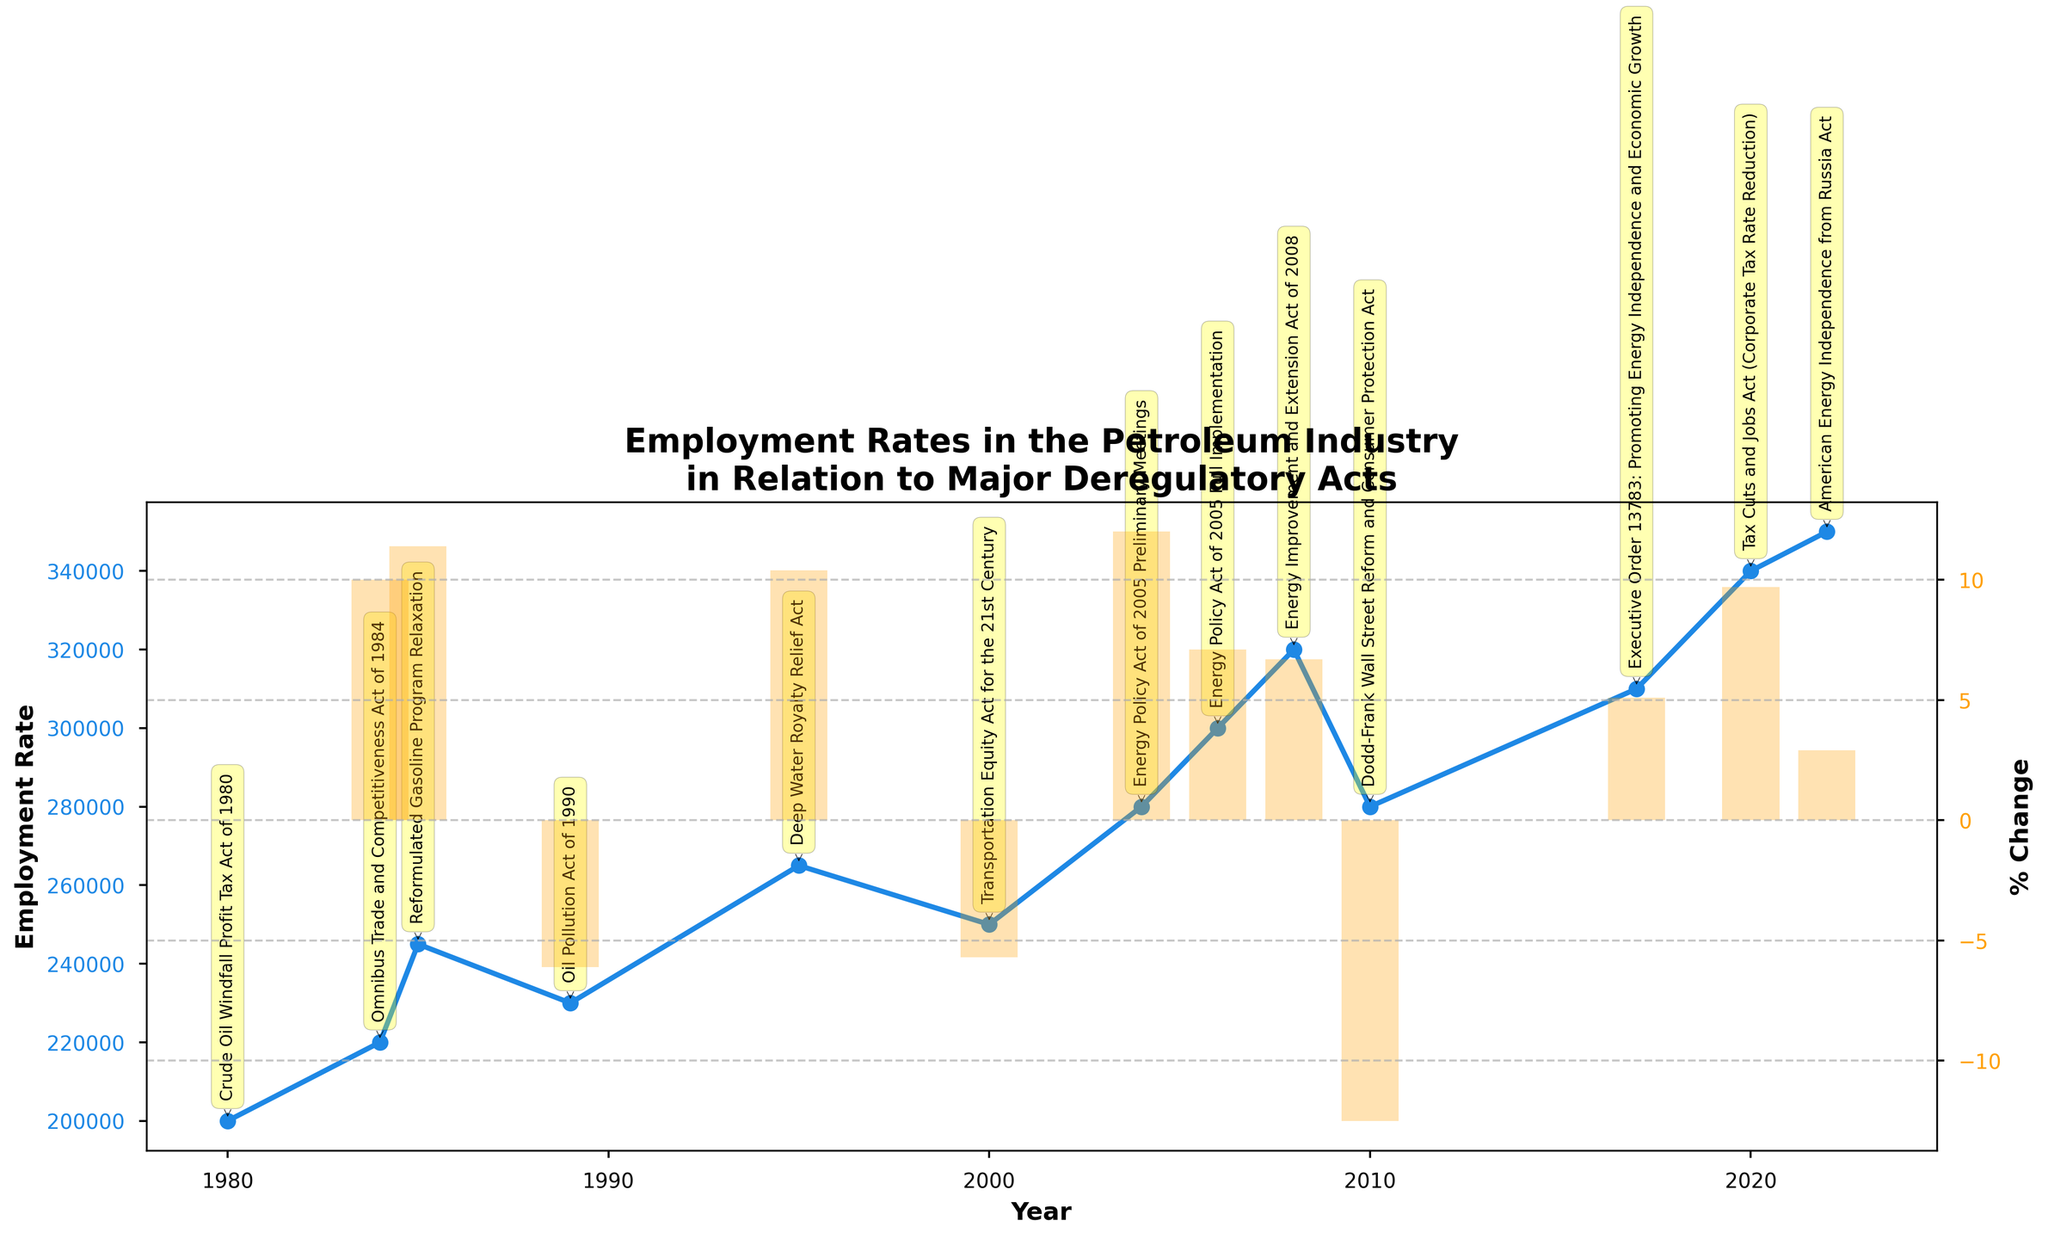What is the title of the figure? The title of the figure is displayed at the top and usually encapsulates the overall theme or purpose of the figure. Here it reads: 'Employment Rates in the Petroleum Industry in Relation to Major Deregulatory Acts'.
Answer: Employment Rates in the Petroleum Industry in Relation to Major Deregulatory Acts How many major deregulatory acts are annotated in the figure? By counting the number of deregulatory acts annotated, either from the yellow text boxes or the arrows pointing to specific years, we can determine the total number. There are 12 deregulatory acts annotated.
Answer: 12 What trend is observed in the employment rate between 1984 and 1985? Observing the line graph, the employment rate rose from 220,000 in 1984 to 245,000 in 1985.
Answer: Increased Which year shows the highest employment rate in the petroleum industry? Referring to the plot, the employment rate peaks at 350,000 in the year 2022.
Answer: 2022 What is the percentage change in employment rate in 2010, and what might have contributed to it? The bar corresponding to 2010 shows a -12.5% change, the largest negative percentage change. The annotated act in 2010 is the Dodd-Frank Wall Street Reform and Consumer Protection Act, indicating regulatory tightening.
Answer: -12.5% Compare the employment rates before and after the implementation of the Energy Policy Act of 2005. Looking at the rates before and after the Energy Policy Act in 2005, employment increased from 250,000 in 2000 to 280,000 in 2004, and further increased to 300,000 by 2006.
Answer: Increased What was the employment rate before the introduction of the Crude Oil Windfall Profit Tax Act of 1980, and what was the employment rate in 1980? How did the employment rate change? Before the Crude Oil Windfall Profit Tax Act of 1980, we do not have data for the prior years in the figure. In 1980, the employment rate was 200,000. There's no recorded previous rate for direct comparison in this dataset.
Answer: 200,000 What is the overall trend in the petroleum industry employment rate from 1980 to 2022? Observing the plot from the leftmost part in 1980 to the rightmost part in 2022, the overall trend is an upward trajectory despite several fluctuations.
Answer: Upward trend Which two consecutive years after 2010 show the largest employment rate increase? Examining the yearly changes post-2010, the largest increase is from 2017 (310,000) to 2020 (340,000), a rise of 30,000.
Answer: 2017 to 2020 